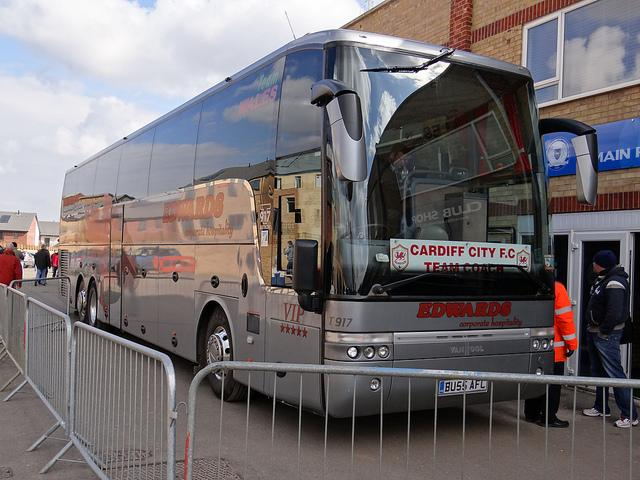Why is the man wearing an orange vest? Please explain your reasoning. visibility. The man needs visibility. 